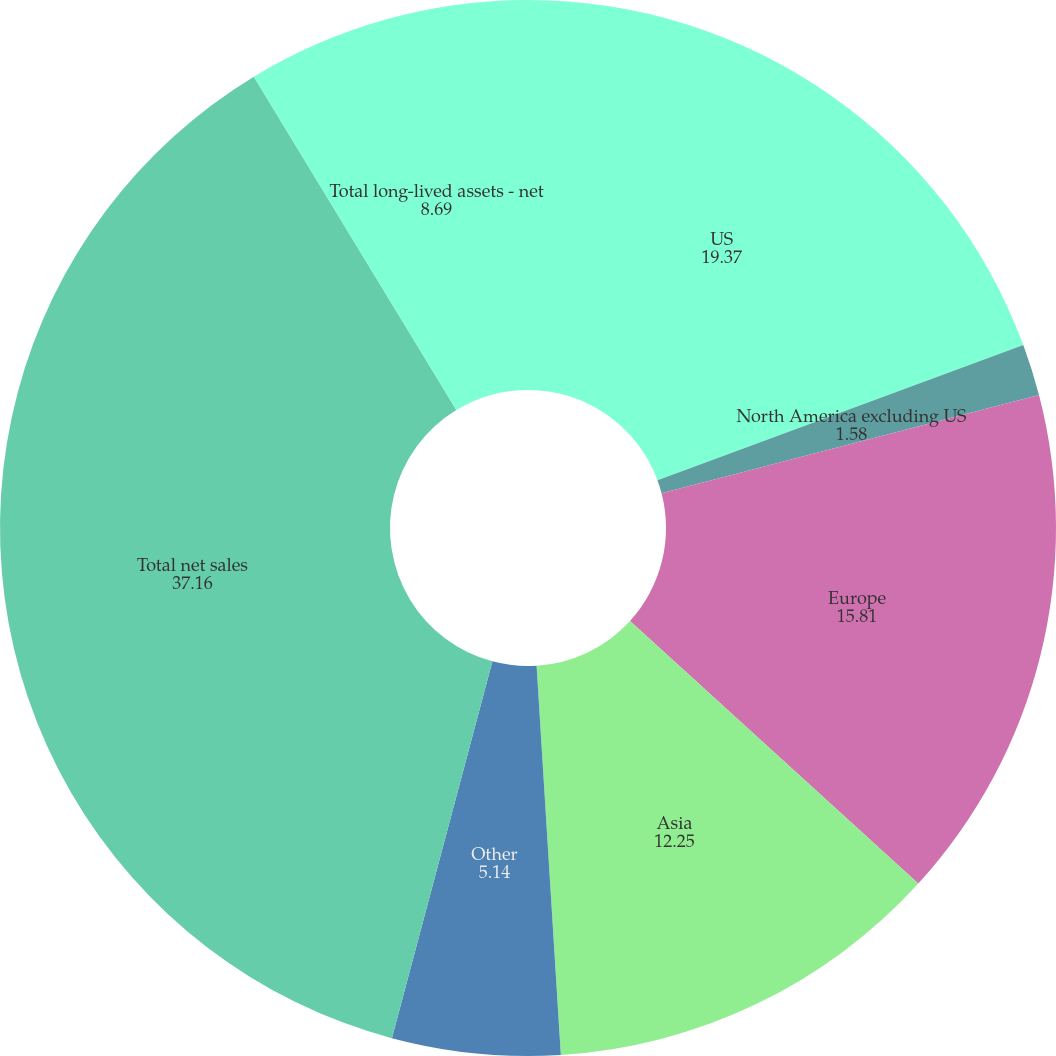Convert chart to OTSL. <chart><loc_0><loc_0><loc_500><loc_500><pie_chart><fcel>US<fcel>North America excluding US<fcel>Europe<fcel>Asia<fcel>Other<fcel>Total net sales<fcel>Total long-lived assets - net<nl><fcel>19.37%<fcel>1.58%<fcel>15.81%<fcel>12.25%<fcel>5.14%<fcel>37.16%<fcel>8.69%<nl></chart> 